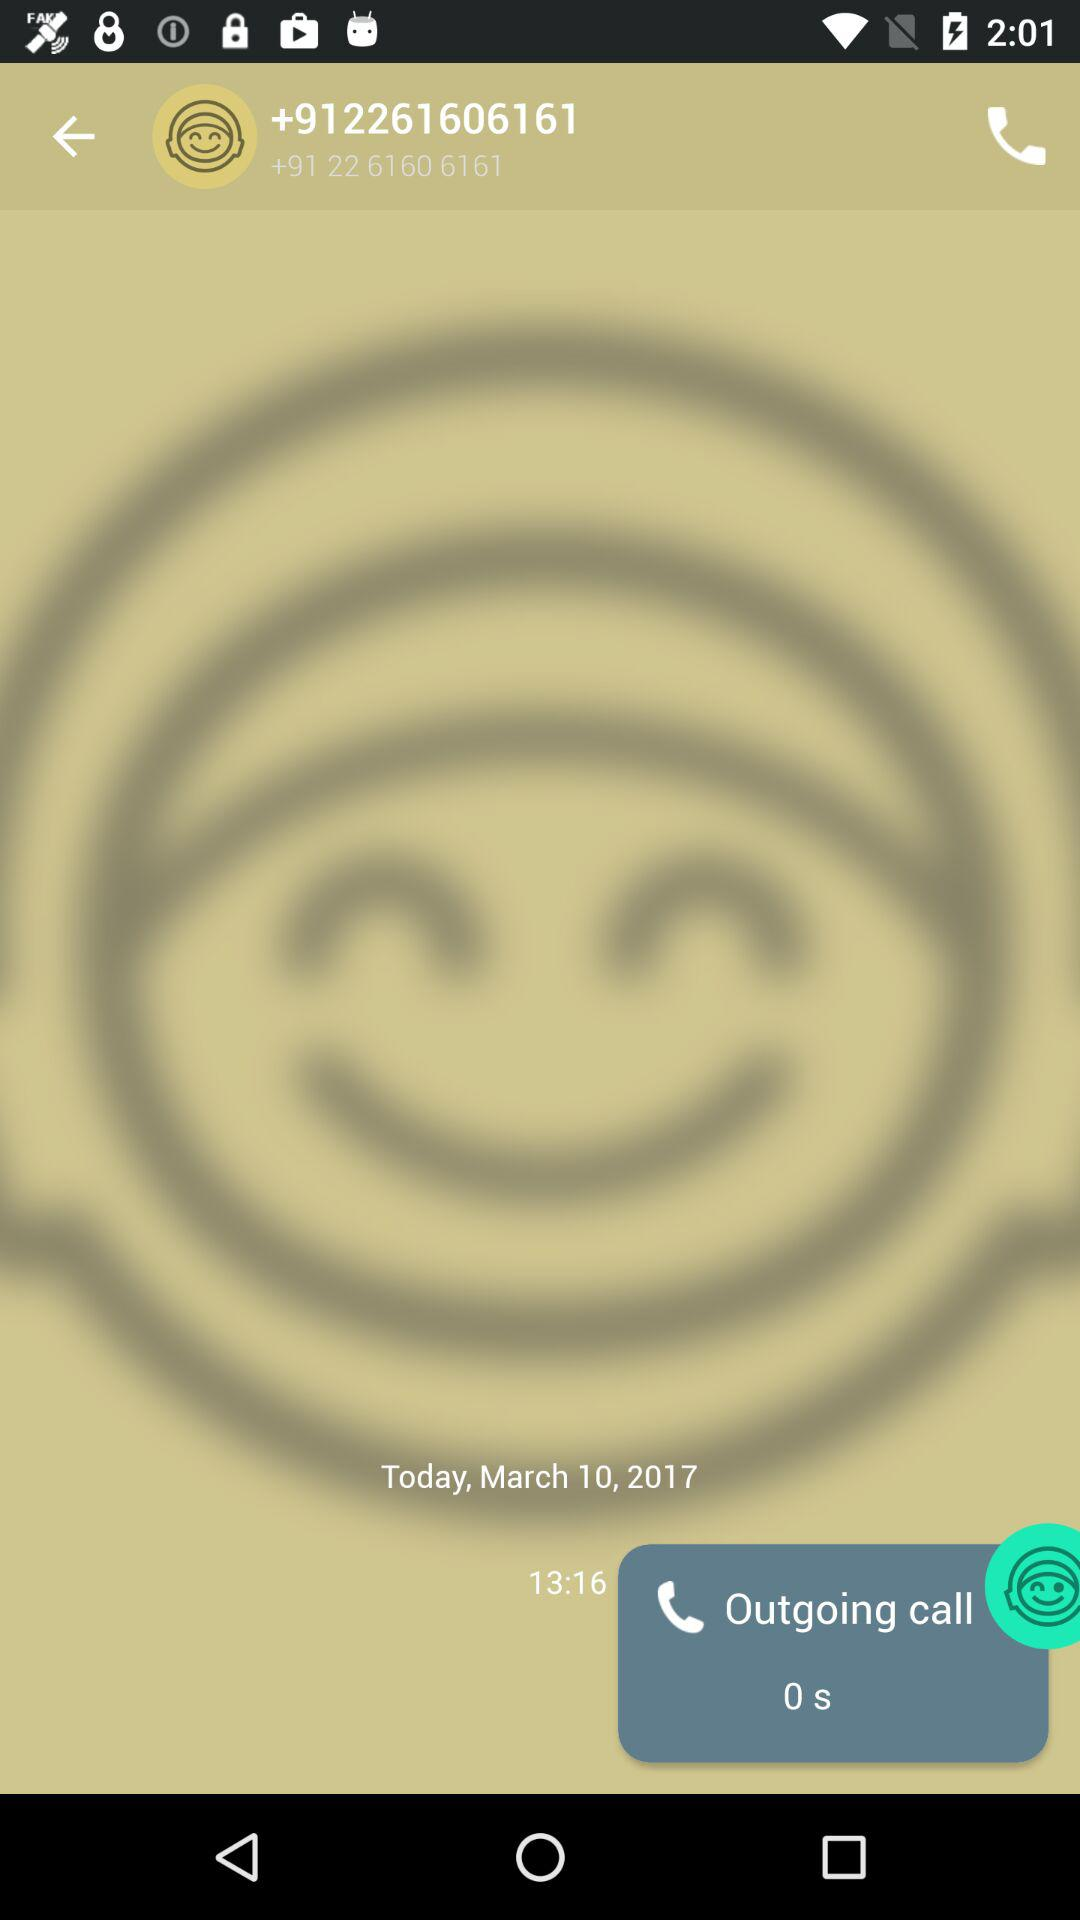How many minutes has the call been going on for?
Answer the question using a single word or phrase. 0 